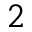Convert formula to latex. <formula><loc_0><loc_0><loc_500><loc_500>2</formula> 